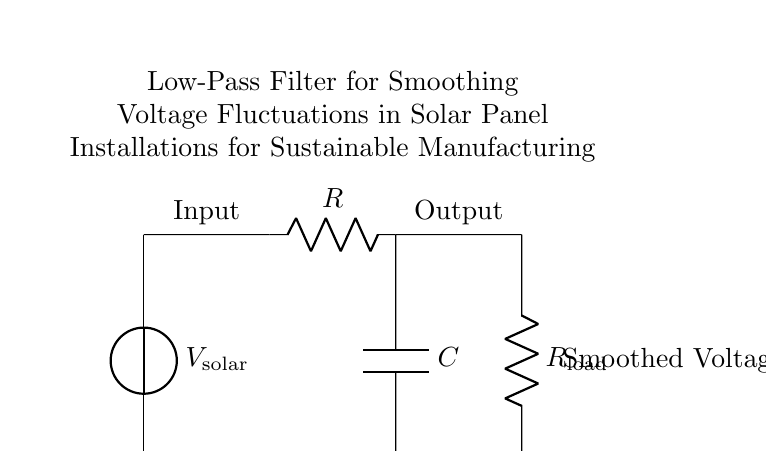What is the input voltage source labeled as? The input voltage source is labeled as "V solar," indicating it's the voltage generated by the solar panels.
Answer: V solar What components are included in the low-pass filter? The low-pass filter consists of a resistor labeled "R" and a capacitor labeled "C." These components are critical for filtering out high-frequency noise and allowing low-frequency signals to pass through.
Answer: R and C What does the output label indicate? The output label indicates where the smoothed voltage emerges from the circuit after the low-pass filtering process. This voltage reflects a more stable signal compared to the input.
Answer: Smoothed Voltage What is the function of the load resistor in this circuit? The load resistor, labeled "R load," is connected to the output of the low-pass filter and represents the component or device that consumes the filtered, smoothed voltage signal provided by the circuit.
Answer: R load What effect does increasing the resistor value R have on the filter? Increasing the resistor value R would lower the cutoff frequency of the low-pass filter, allowing less high-frequency noise to pass and leading to a smoother output voltage, but potentially slowing the response time to changes in the input voltage.
Answer: Lower cutoff frequency What type of filter is used in this circuit? The circuit demonstrates a low-pass filter, which allows signals with a frequency lower than a certain cutoff frequency to pass through while attenuating higher frequencies. This feature is essential in smoothing voltage fluctuations.
Answer: Low-pass filter How does the capacitor affect the voltage at the output? The capacitor stores charge and helps to smooth out fluctuations by releasing energy slowly, which results in a more constant voltage at the output. If fluctuations occur, the capacitor acts to buffer them, leading to a steadier output signal.
Answer: Smooths voltage 